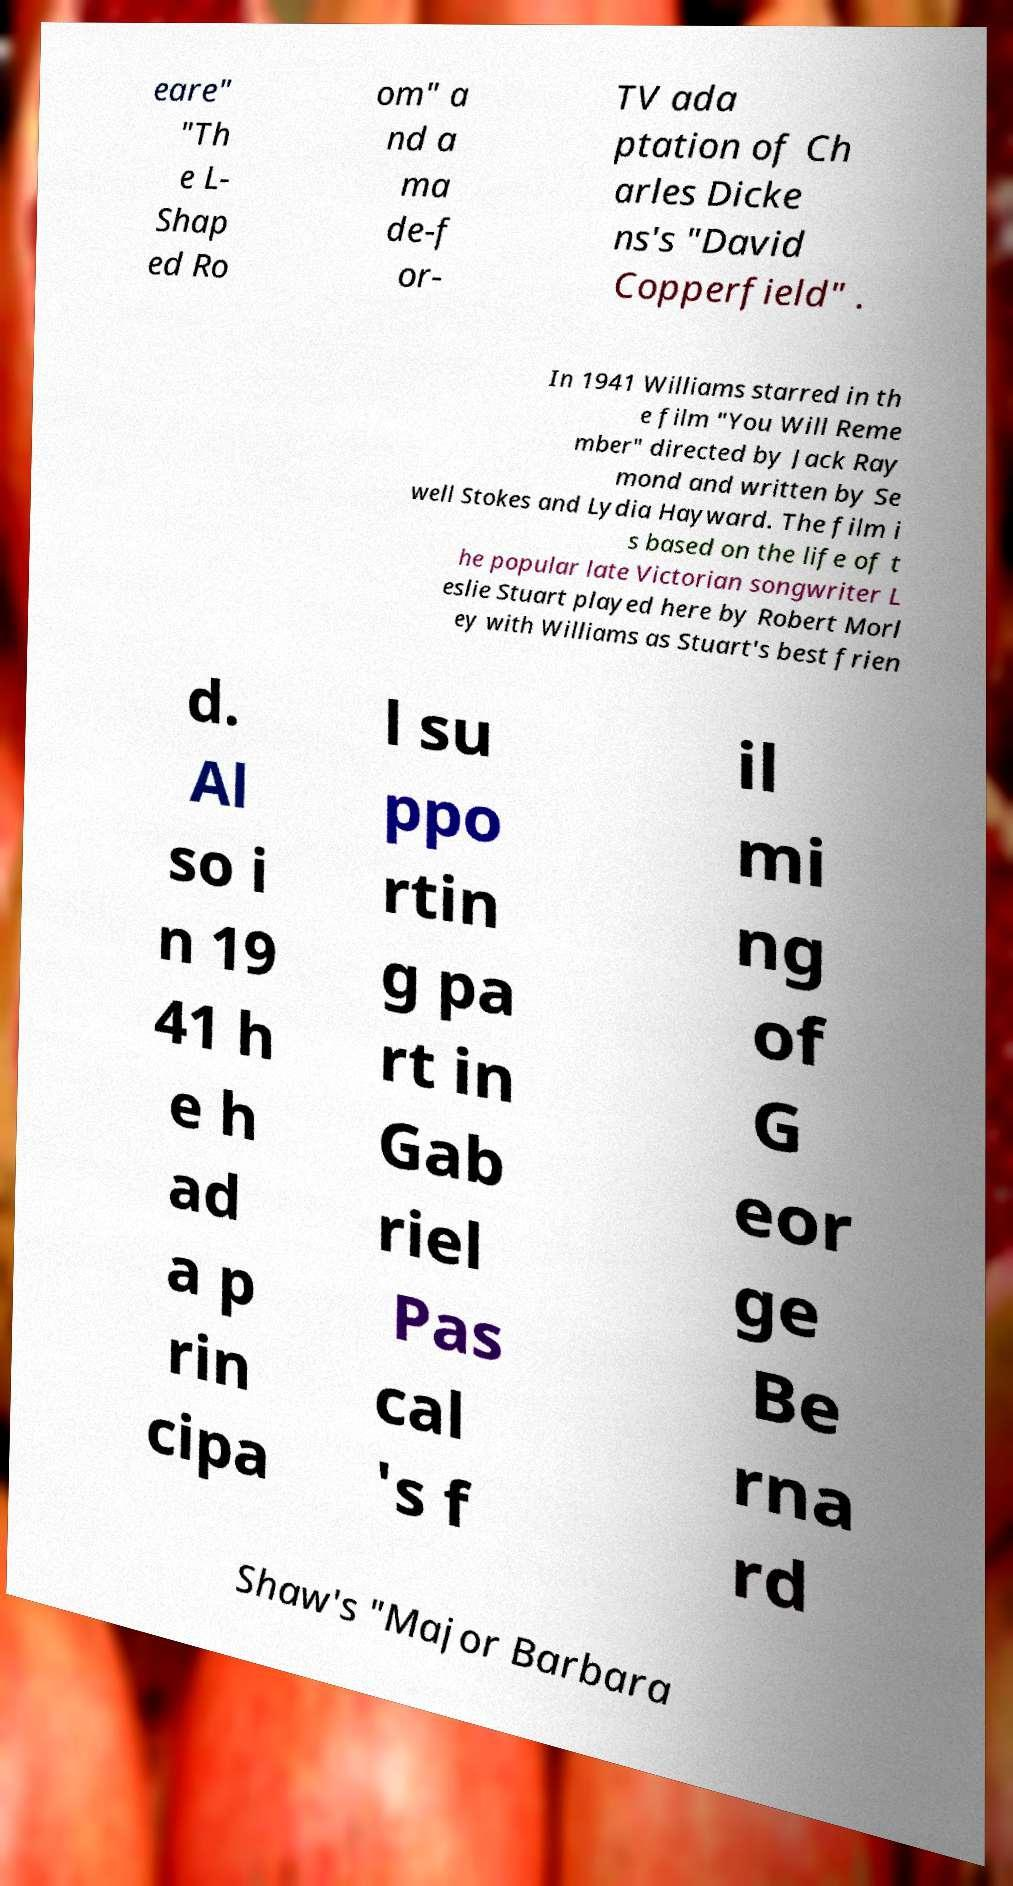Could you assist in decoding the text presented in this image and type it out clearly? eare" "Th e L- Shap ed Ro om" a nd a ma de-f or- TV ada ptation of Ch arles Dicke ns's "David Copperfield" . In 1941 Williams starred in th e film "You Will Reme mber" directed by Jack Ray mond and written by Se well Stokes and Lydia Hayward. The film i s based on the life of t he popular late Victorian songwriter L eslie Stuart played here by Robert Morl ey with Williams as Stuart's best frien d. Al so i n 19 41 h e h ad a p rin cipa l su ppo rtin g pa rt in Gab riel Pas cal 's f il mi ng of G eor ge Be rna rd Shaw's "Major Barbara 